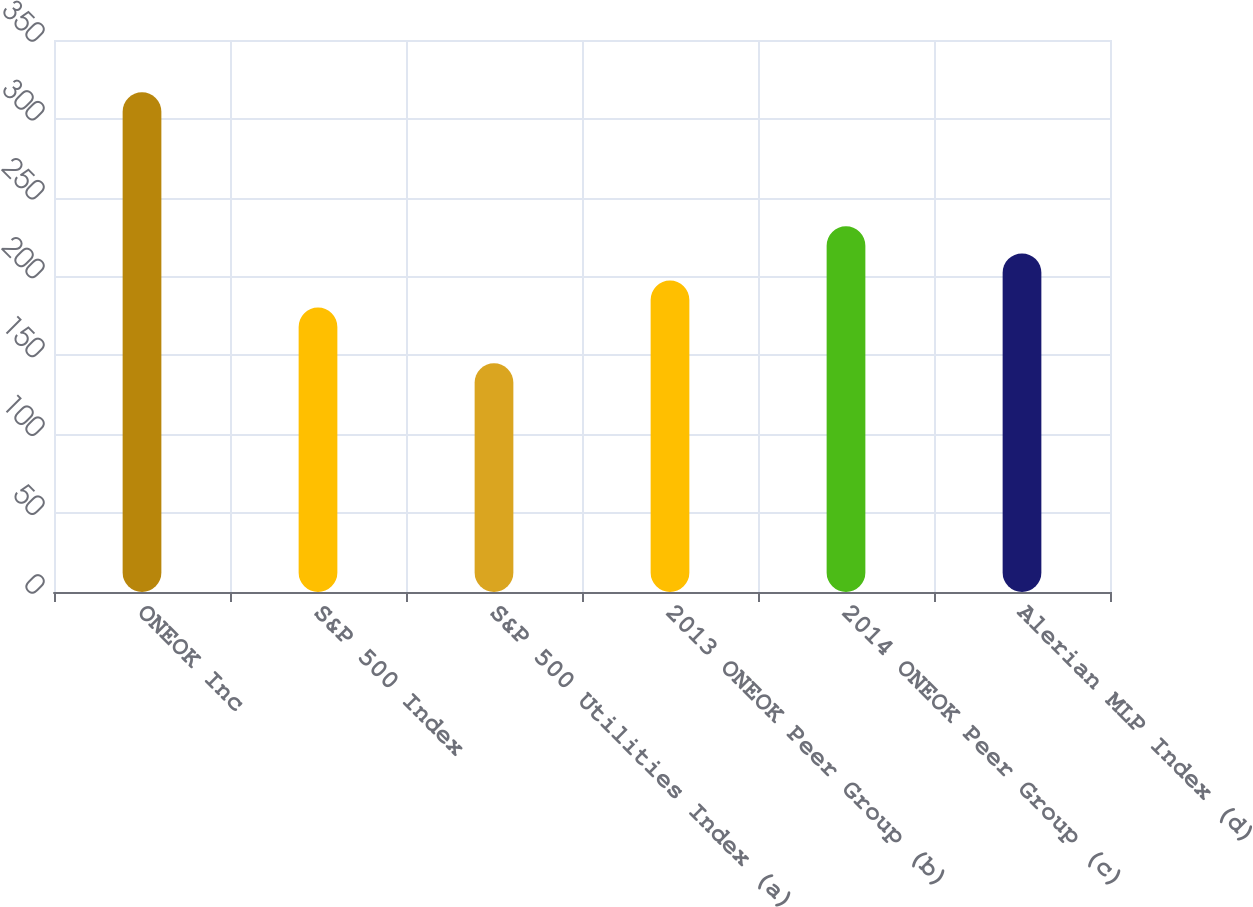<chart> <loc_0><loc_0><loc_500><loc_500><bar_chart><fcel>ONEOK Inc<fcel>S&P 500 Index<fcel>S&P 500 Utilities Index (a)<fcel>2013 ONEOK Peer Group (b)<fcel>2014 ONEOK Peer Group (c)<fcel>Alerian MLP Index (d)<nl><fcel>316.83<fcel>180.33<fcel>145.04<fcel>197.51<fcel>231.87<fcel>214.69<nl></chart> 